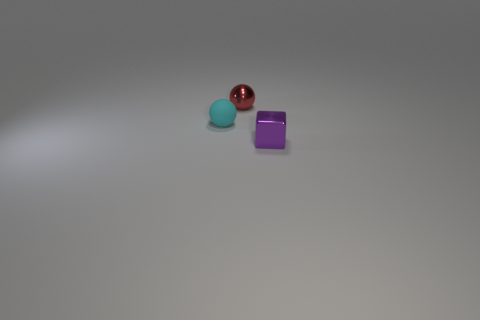There is a metallic thing that is in front of the tiny object behind the cyan object; what is its shape?
Make the answer very short. Cube. What shape is the tiny red shiny thing?
Give a very brief answer. Sphere. Does the matte thing have the same shape as the shiny object on the left side of the purple metallic cube?
Keep it short and to the point. Yes. Do the small shiny thing behind the tiny cube and the purple shiny object have the same shape?
Your answer should be compact. No. How many things are both to the right of the small cyan matte thing and behind the cube?
Offer a very short reply. 1. What number of other objects are the same size as the matte object?
Provide a short and direct response. 2. Are there an equal number of cyan spheres right of the tiny red shiny sphere and green metallic spheres?
Make the answer very short. Yes. There is a small sphere that is behind the small matte object; does it have the same color as the tiny sphere that is in front of the small red sphere?
Ensure brevity in your answer.  No. There is a thing that is behind the purple shiny thing and in front of the red thing; what material is it made of?
Provide a succinct answer. Rubber. The metallic cube has what color?
Ensure brevity in your answer.  Purple. 